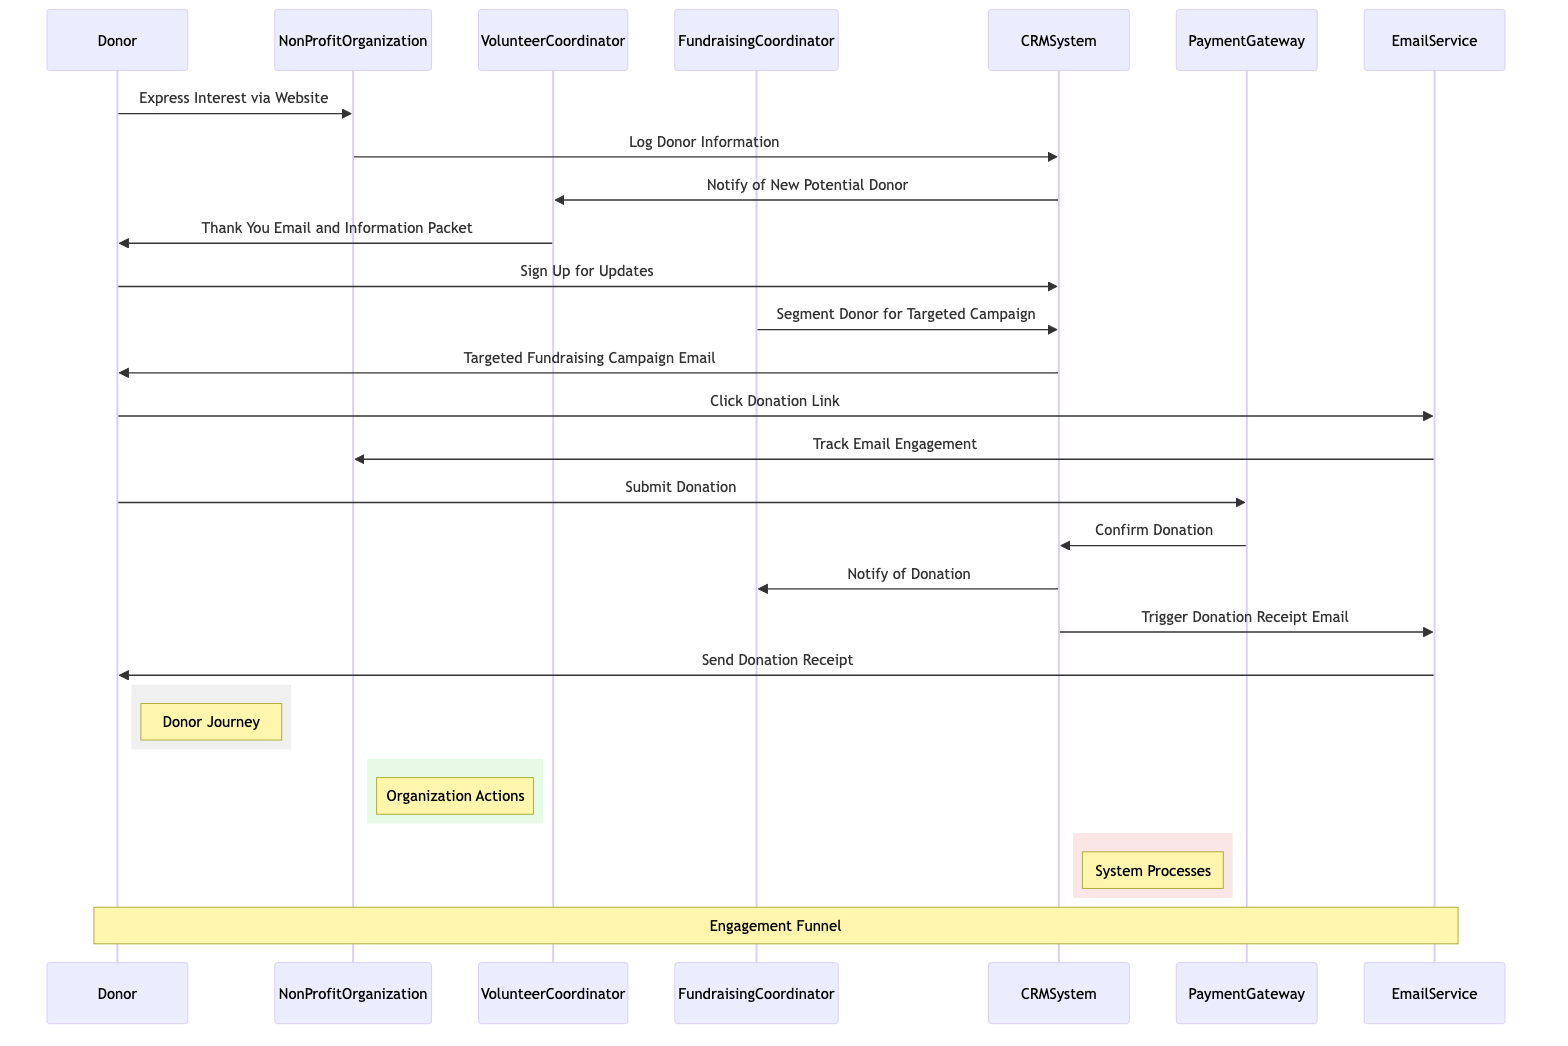What is the first message exchanged in the diagram? The first message is exchanged from the Donor to the NonProfitOrganization, which is "Express Interest via Website".
Answer: Express Interest via Website How many participants are involved in the sequence diagram? There are six participants involved, which are Donor, NonProfitOrganization, VolunteerCoordinator, FundraisingCoordinator, CRMSystem, PaymentGateway, and EmailService.
Answer: Six What role does the CRMSystem play in the engagement process? The CRMSystem logs donor information, notifies the VolunteerCoordinator of new potential donors, segments the donor for targeted campaigns, and confirms donations.
Answer: Central role Which participant sends a thank you email to the donor? The VolunteerCoordinator sends a thank you email to the donor.
Answer: VolunteerCoordinator What is the last action taken in the sequence? The last action taken in the sequence is the EmailService sending the donation receipt to the donor.
Answer: Send Donation Receipt Explain the flow from donation link click to donation receipt email. After the Donor clicks the donation link, it sends a request to the EmailService to track email engagement. The Donor then submits the donation to the PaymentGateway, which confirms the donation to the CRMSystem. The CRMSystem then notifies the FundraisingCoordinator and triggers the EmailService to send a donation receipt email to the Donor.
Answer: Click, Submit, Confirm, Notify, Trigger, Send What type of communication occurs after segmenting the donor? After segmenting the donor, the CRMSystem sends a targeted fundraising campaign email to the Donor.
Answer: Targeted fundraising campaign email How does the diagram indicate donor engagement tracking? The EmailService tracks engagement through an interaction with the NonProfitOrganization after the Donor clicks on the donation link.
Answer: Track Email Engagement 